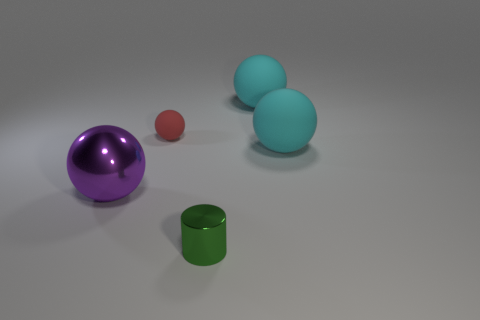What could be the possible material composition of the objects? The surfaces of the objects depicted suggest various material compositions. The purple and blue spheres exhibit a glossy finish, indicative of a glass or plastic material. The green cylinder appears to have a matte finish akin to painted metal, while the small red sphere has a diffuse, possibly rubberized surface. 